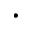<formula> <loc_0><loc_0><loc_500><loc_500>\cdot</formula> 